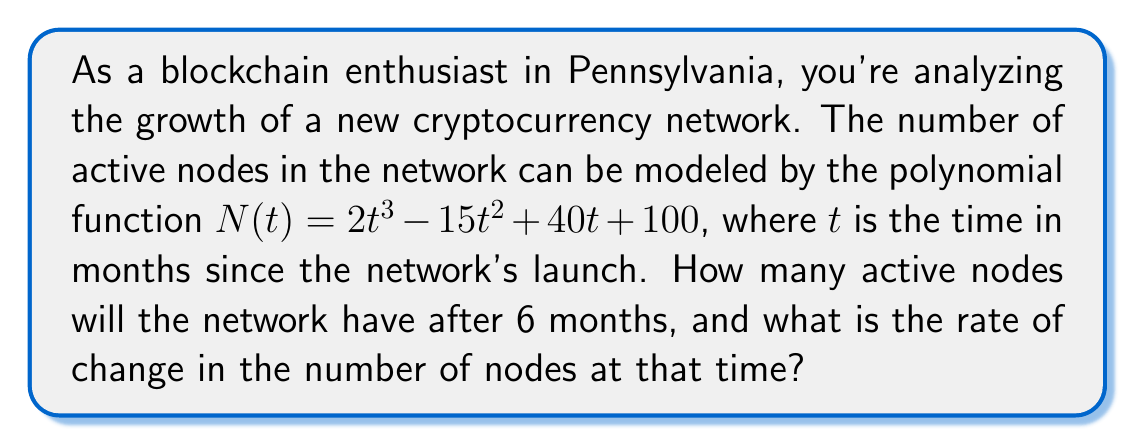Can you solve this math problem? To solve this problem, we'll follow these steps:

1. Calculate the number of active nodes after 6 months:
   Substitute $t = 6$ into the given function $N(t)$.
   
   $$N(6) = 2(6^3) - 15(6^2) + 40(6) + 100$$
   $$= 2(216) - 15(36) + 40(6) + 100$$
   $$= 432 - 540 + 240 + 100$$
   $$= 232$$

2. Find the rate of change at 6 months:
   The rate of change is given by the first derivative of $N(t)$ evaluated at $t = 6$.
   
   First, let's find $N'(t)$:
   $$N'(t) = 6t^2 - 30t + 40$$
   
   Now, evaluate $N'(6)$:
   $$N'(6) = 6(6^2) - 30(6) + 40$$
   $$= 6(36) - 180 + 40$$
   $$= 216 - 180 + 40$$
   $$= 76$$

Therefore, after 6 months, the network will have 232 active nodes, and the rate of change at that time is 76 nodes per month.
Answer: 232 nodes; 76 nodes/month 